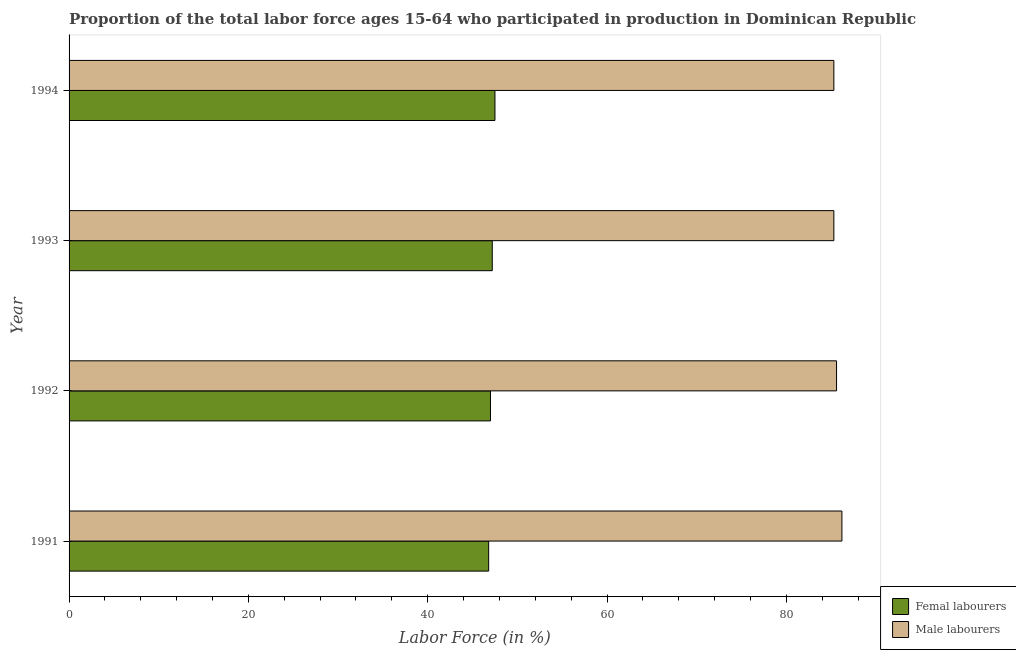Are the number of bars on each tick of the Y-axis equal?
Your response must be concise. Yes. What is the percentage of female labor force in 1991?
Offer a very short reply. 46.8. Across all years, what is the maximum percentage of male labour force?
Your answer should be very brief. 86.2. Across all years, what is the minimum percentage of female labor force?
Keep it short and to the point. 46.8. In which year was the percentage of female labor force maximum?
Keep it short and to the point. 1994. What is the total percentage of male labour force in the graph?
Offer a terse response. 342.4. What is the difference between the percentage of male labour force in 1992 and the percentage of female labor force in 1993?
Offer a very short reply. 38.4. What is the average percentage of female labor force per year?
Your response must be concise. 47.12. In the year 1994, what is the difference between the percentage of female labor force and percentage of male labour force?
Your answer should be compact. -37.8. In how many years, is the percentage of female labor force greater than 44 %?
Ensure brevity in your answer.  4. What is the ratio of the percentage of female labor force in 1991 to that in 1994?
Give a very brief answer. 0.98. What does the 1st bar from the top in 1993 represents?
Ensure brevity in your answer.  Male labourers. What does the 2nd bar from the bottom in 1993 represents?
Make the answer very short. Male labourers. How many bars are there?
Offer a terse response. 8. Does the graph contain grids?
Provide a succinct answer. No. How are the legend labels stacked?
Your answer should be compact. Vertical. What is the title of the graph?
Your answer should be compact. Proportion of the total labor force ages 15-64 who participated in production in Dominican Republic. Does "IMF nonconcessional" appear as one of the legend labels in the graph?
Your response must be concise. No. What is the label or title of the Y-axis?
Give a very brief answer. Year. What is the Labor Force (in %) of Femal labourers in 1991?
Your response must be concise. 46.8. What is the Labor Force (in %) in Male labourers in 1991?
Your response must be concise. 86.2. What is the Labor Force (in %) in Femal labourers in 1992?
Give a very brief answer. 47. What is the Labor Force (in %) of Male labourers in 1992?
Offer a very short reply. 85.6. What is the Labor Force (in %) of Femal labourers in 1993?
Give a very brief answer. 47.2. What is the Labor Force (in %) of Male labourers in 1993?
Your answer should be compact. 85.3. What is the Labor Force (in %) in Femal labourers in 1994?
Your answer should be compact. 47.5. What is the Labor Force (in %) of Male labourers in 1994?
Keep it short and to the point. 85.3. Across all years, what is the maximum Labor Force (in %) in Femal labourers?
Provide a short and direct response. 47.5. Across all years, what is the maximum Labor Force (in %) in Male labourers?
Provide a short and direct response. 86.2. Across all years, what is the minimum Labor Force (in %) in Femal labourers?
Offer a terse response. 46.8. Across all years, what is the minimum Labor Force (in %) in Male labourers?
Offer a very short reply. 85.3. What is the total Labor Force (in %) of Femal labourers in the graph?
Ensure brevity in your answer.  188.5. What is the total Labor Force (in %) of Male labourers in the graph?
Your answer should be very brief. 342.4. What is the difference between the Labor Force (in %) in Male labourers in 1991 and that in 1993?
Offer a terse response. 0.9. What is the difference between the Labor Force (in %) of Male labourers in 1991 and that in 1994?
Provide a succinct answer. 0.9. What is the difference between the Labor Force (in %) of Femal labourers in 1992 and that in 1994?
Offer a very short reply. -0.5. What is the difference between the Labor Force (in %) of Femal labourers in 1991 and the Labor Force (in %) of Male labourers in 1992?
Offer a terse response. -38.8. What is the difference between the Labor Force (in %) of Femal labourers in 1991 and the Labor Force (in %) of Male labourers in 1993?
Your response must be concise. -38.5. What is the difference between the Labor Force (in %) in Femal labourers in 1991 and the Labor Force (in %) in Male labourers in 1994?
Offer a very short reply. -38.5. What is the difference between the Labor Force (in %) in Femal labourers in 1992 and the Labor Force (in %) in Male labourers in 1993?
Your response must be concise. -38.3. What is the difference between the Labor Force (in %) in Femal labourers in 1992 and the Labor Force (in %) in Male labourers in 1994?
Provide a succinct answer. -38.3. What is the difference between the Labor Force (in %) in Femal labourers in 1993 and the Labor Force (in %) in Male labourers in 1994?
Offer a very short reply. -38.1. What is the average Labor Force (in %) of Femal labourers per year?
Provide a succinct answer. 47.12. What is the average Labor Force (in %) in Male labourers per year?
Offer a very short reply. 85.6. In the year 1991, what is the difference between the Labor Force (in %) of Femal labourers and Labor Force (in %) of Male labourers?
Offer a very short reply. -39.4. In the year 1992, what is the difference between the Labor Force (in %) in Femal labourers and Labor Force (in %) in Male labourers?
Ensure brevity in your answer.  -38.6. In the year 1993, what is the difference between the Labor Force (in %) of Femal labourers and Labor Force (in %) of Male labourers?
Provide a succinct answer. -38.1. In the year 1994, what is the difference between the Labor Force (in %) of Femal labourers and Labor Force (in %) of Male labourers?
Ensure brevity in your answer.  -37.8. What is the ratio of the Labor Force (in %) in Femal labourers in 1991 to that in 1992?
Ensure brevity in your answer.  1. What is the ratio of the Labor Force (in %) in Male labourers in 1991 to that in 1992?
Give a very brief answer. 1.01. What is the ratio of the Labor Force (in %) of Femal labourers in 1991 to that in 1993?
Your answer should be compact. 0.99. What is the ratio of the Labor Force (in %) of Male labourers in 1991 to that in 1993?
Offer a terse response. 1.01. What is the ratio of the Labor Force (in %) in Male labourers in 1991 to that in 1994?
Ensure brevity in your answer.  1.01. What is the ratio of the Labor Force (in %) of Femal labourers in 1992 to that in 1993?
Your answer should be very brief. 1. What is the ratio of the Labor Force (in %) of Femal labourers in 1992 to that in 1994?
Your answer should be compact. 0.99. What is the ratio of the Labor Force (in %) of Femal labourers in 1993 to that in 1994?
Your response must be concise. 0.99. What is the difference between the highest and the second highest Labor Force (in %) of Femal labourers?
Provide a short and direct response. 0.3. 